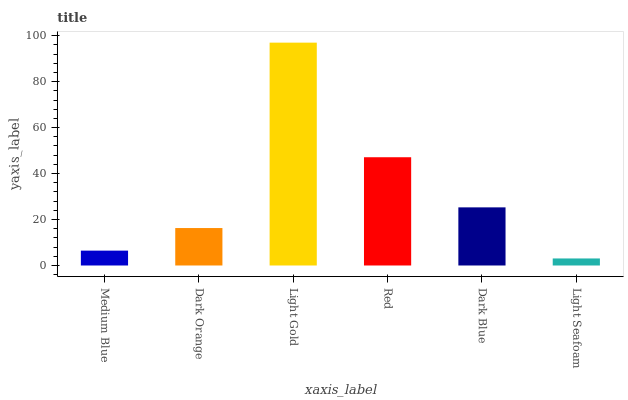Is Light Gold the maximum?
Answer yes or no. Yes. Is Dark Orange the minimum?
Answer yes or no. No. Is Dark Orange the maximum?
Answer yes or no. No. Is Dark Orange greater than Medium Blue?
Answer yes or no. Yes. Is Medium Blue less than Dark Orange?
Answer yes or no. Yes. Is Medium Blue greater than Dark Orange?
Answer yes or no. No. Is Dark Orange less than Medium Blue?
Answer yes or no. No. Is Dark Blue the high median?
Answer yes or no. Yes. Is Dark Orange the low median?
Answer yes or no. Yes. Is Dark Orange the high median?
Answer yes or no. No. Is Light Gold the low median?
Answer yes or no. No. 